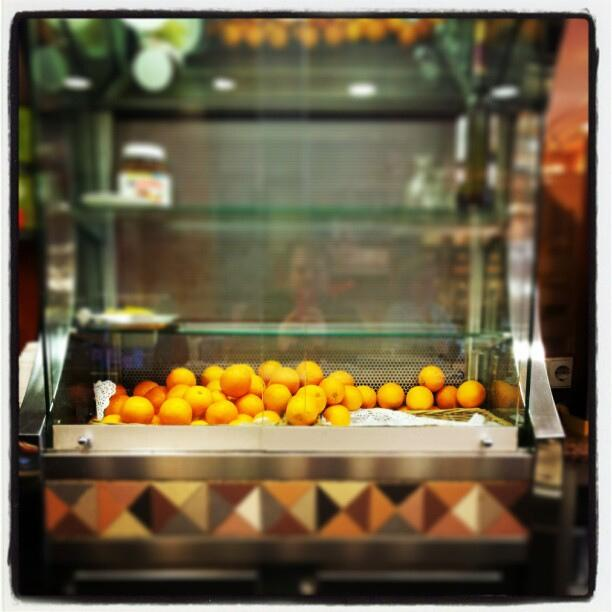What vitamin does this fruit contain the most?

Choices:
A) vitamin
B) vitamin b
C) vitamin c
D) vitamin e vitamin c 